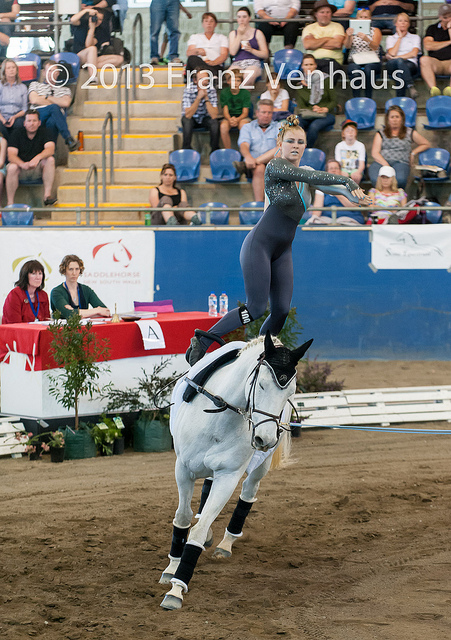Read and extract the text from this image. 2013 Franz Venhaus A 100 